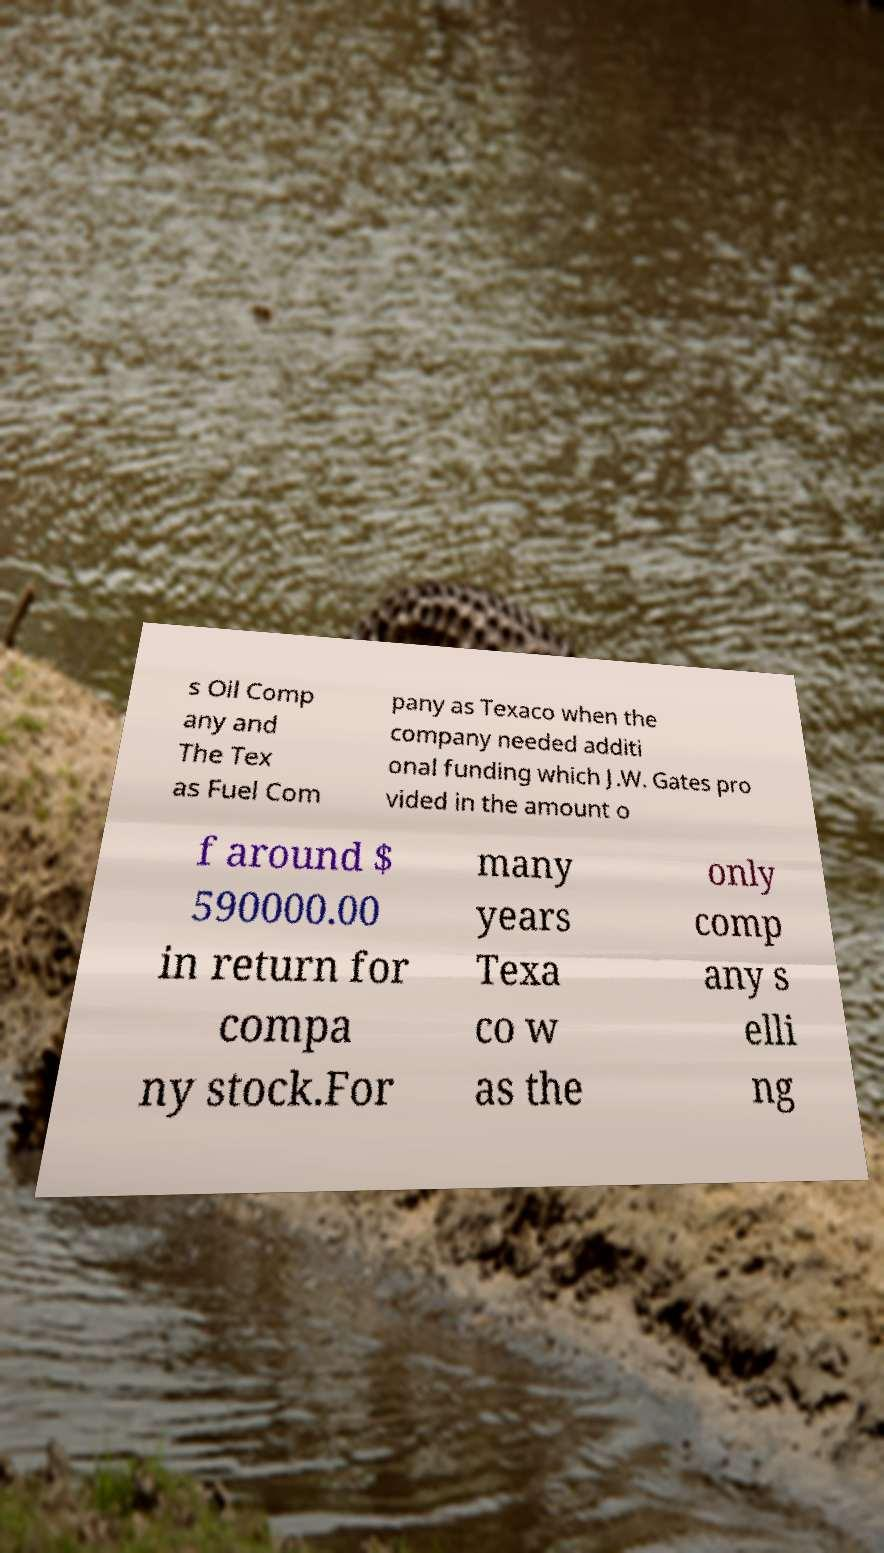Please read and relay the text visible in this image. What does it say? s Oil Comp any and The Tex as Fuel Com pany as Texaco when the company needed additi onal funding which J.W. Gates pro vided in the amount o f around $ 590000.00 in return for compa ny stock.For many years Texa co w as the only comp any s elli ng 